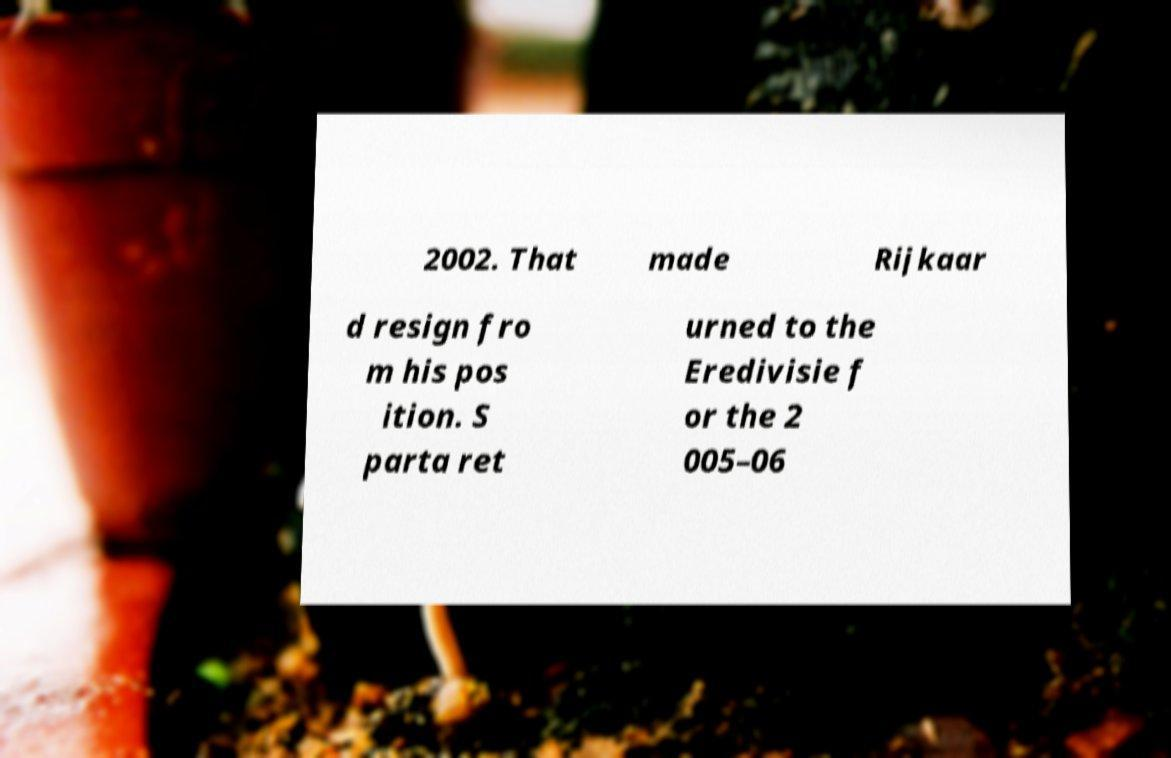Can you read and provide the text displayed in the image?This photo seems to have some interesting text. Can you extract and type it out for me? 2002. That made Rijkaar d resign fro m his pos ition. S parta ret urned to the Eredivisie f or the 2 005–06 